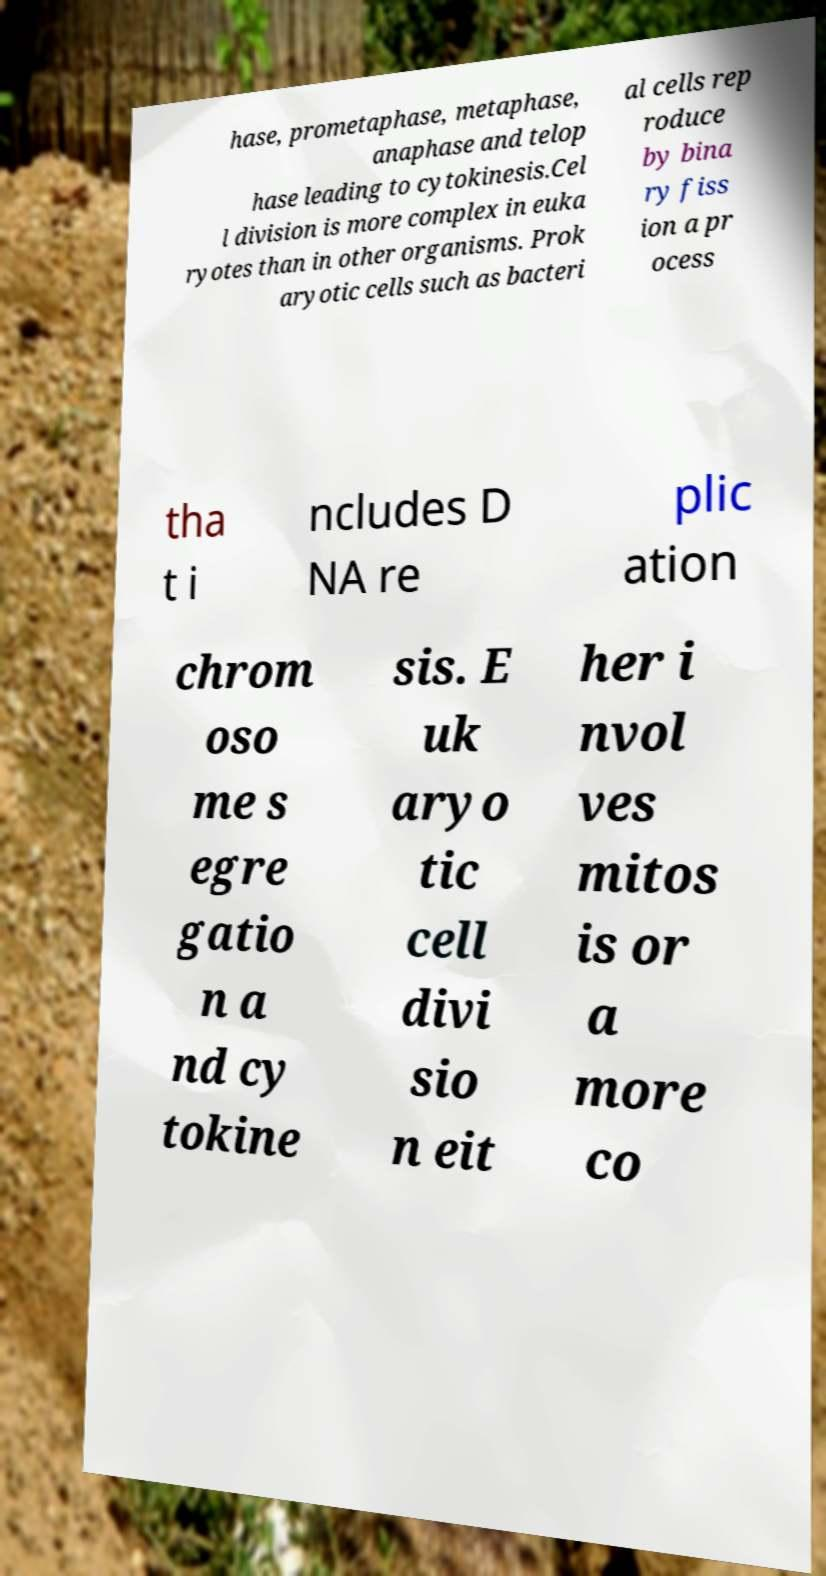I need the written content from this picture converted into text. Can you do that? hase, prometaphase, metaphase, anaphase and telop hase leading to cytokinesis.Cel l division is more complex in euka ryotes than in other organisms. Prok aryotic cells such as bacteri al cells rep roduce by bina ry fiss ion a pr ocess tha t i ncludes D NA re plic ation chrom oso me s egre gatio n a nd cy tokine sis. E uk aryo tic cell divi sio n eit her i nvol ves mitos is or a more co 